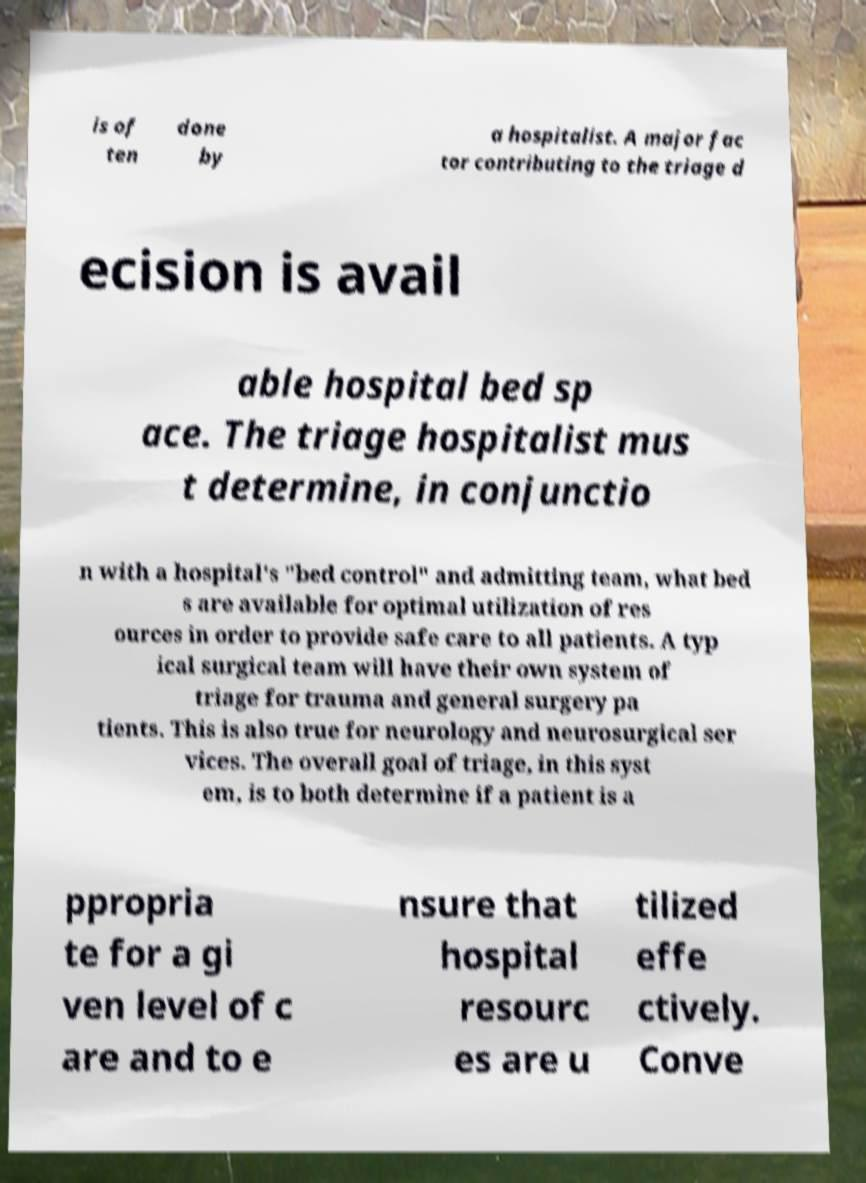Could you extract and type out the text from this image? is of ten done by a hospitalist. A major fac tor contributing to the triage d ecision is avail able hospital bed sp ace. The triage hospitalist mus t determine, in conjunctio n with a hospital's "bed control" and admitting team, what bed s are available for optimal utilization of res ources in order to provide safe care to all patients. A typ ical surgical team will have their own system of triage for trauma and general surgery pa tients. This is also true for neurology and neurosurgical ser vices. The overall goal of triage, in this syst em, is to both determine if a patient is a ppropria te for a gi ven level of c are and to e nsure that hospital resourc es are u tilized effe ctively. Conve 